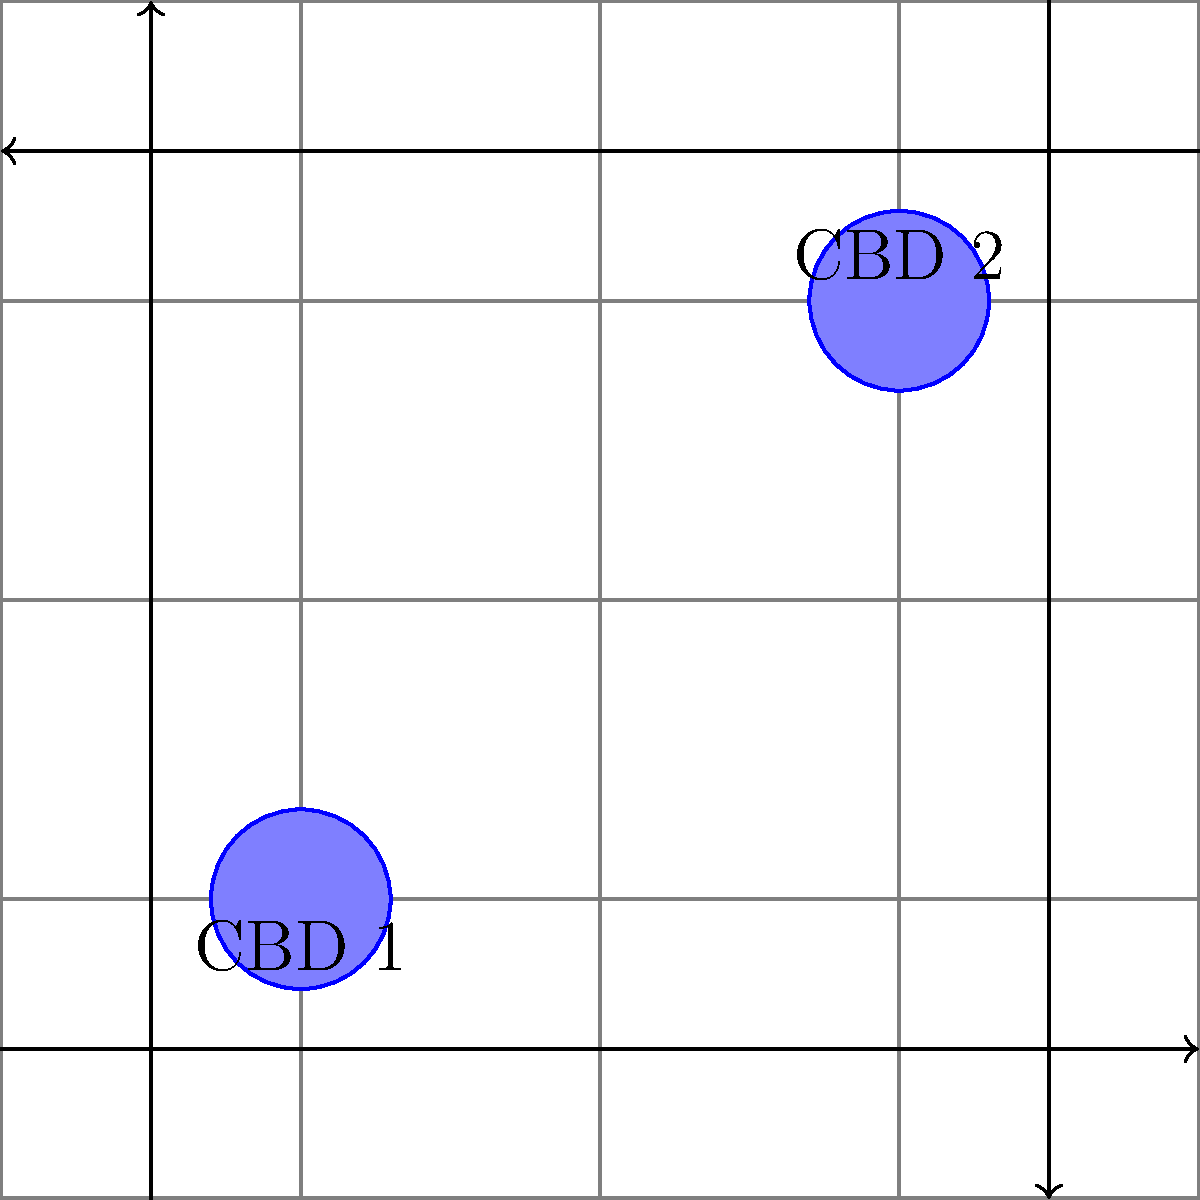Analyze the traffic flow patterns in relation to the two Central Business Districts (CBDs) shown on the city grid. Which statement best describes the relationship between the traffic flow and the CBD locations? To analyze the traffic flow patterns in relation to the CBD locations, let's follow these steps:

1. Identify the CBD locations:
   - CBD 1 is located at coordinates (1,1)
   - CBD 2 is located at coordinates (3,3)

2. Observe the traffic flow patterns:
   - There are four main traffic flows indicated by arrows
   - Two flows are moving inward towards the center of the grid
   - Two flows are moving outward from the center of the grid

3. Analyze the relationship between traffic flows and CBDs:
   - The inward flows (from left and bottom) converge near CBD 1
   - The outward flows (to right and top) diverge from near CBD 2
   - This pattern suggests a movement from CBD 1 towards CBD 2

4. Interpret the pattern:
   - The traffic flow appears to be moving from the lower-left quadrant (where CBD 1 is located) towards the upper-right quadrant (where CBD 2 is located)
   - This could indicate a morning commute pattern, where people are traveling from a residential area (near CBD 1) to a major employment center (CBD 2)

5. Consider urban development implications:
   - The pattern suggests that CBD 2 might be a more significant employment center or have more attractive amenities
   - CBD 1 might be in a more residential area or have different types of businesses that generate less inbound morning traffic

Given this analysis, the traffic flow pattern shows a clear directional movement from CBD 1 towards CBD 2, suggesting a typical morning commute scenario in urban areas.
Answer: Traffic flows from CBD 1 to CBD 2, indicating a potential morning commute pattern. 